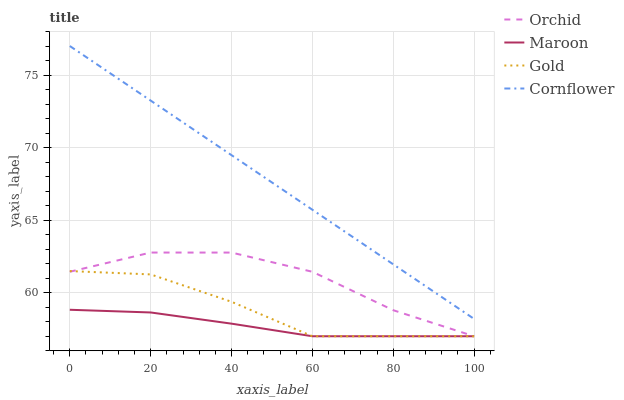Does Maroon have the minimum area under the curve?
Answer yes or no. Yes. Does Cornflower have the maximum area under the curve?
Answer yes or no. Yes. Does Gold have the minimum area under the curve?
Answer yes or no. No. Does Gold have the maximum area under the curve?
Answer yes or no. No. Is Cornflower the smoothest?
Answer yes or no. Yes. Is Orchid the roughest?
Answer yes or no. Yes. Is Gold the smoothest?
Answer yes or no. No. Is Gold the roughest?
Answer yes or no. No. Does Gold have the lowest value?
Answer yes or no. Yes. Does Cornflower have the highest value?
Answer yes or no. Yes. Does Gold have the highest value?
Answer yes or no. No. Is Orchid less than Cornflower?
Answer yes or no. Yes. Is Cornflower greater than Gold?
Answer yes or no. Yes. Does Orchid intersect Gold?
Answer yes or no. Yes. Is Orchid less than Gold?
Answer yes or no. No. Is Orchid greater than Gold?
Answer yes or no. No. Does Orchid intersect Cornflower?
Answer yes or no. No. 